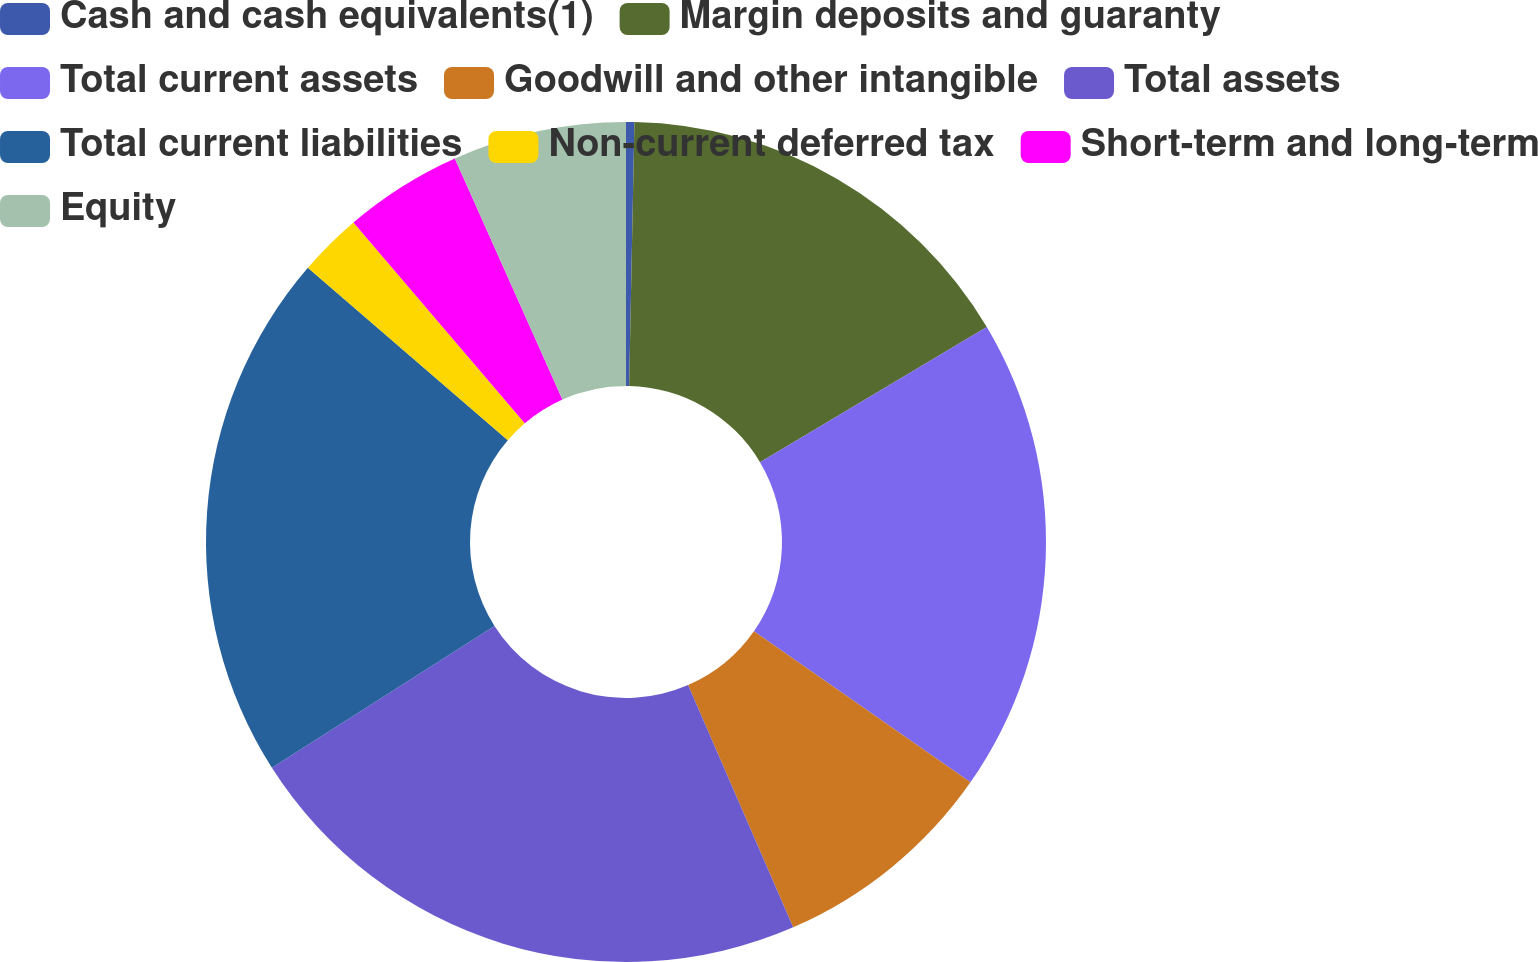Convert chart. <chart><loc_0><loc_0><loc_500><loc_500><pie_chart><fcel>Cash and cash equivalents(1)<fcel>Margin deposits and guaranty<fcel>Total current assets<fcel>Goodwill and other intangible<fcel>Total assets<fcel>Total current liabilities<fcel>Non-current deferred tax<fcel>Short-term and long-term<fcel>Equity<nl><fcel>0.32%<fcel>16.13%<fcel>18.25%<fcel>8.79%<fcel>22.48%<fcel>20.36%<fcel>2.44%<fcel>4.56%<fcel>6.68%<nl></chart> 